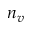Convert formula to latex. <formula><loc_0><loc_0><loc_500><loc_500>n _ { v }</formula> 